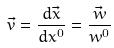<formula> <loc_0><loc_0><loc_500><loc_500>\vec { v } = \frac { d \vec { x } } { d x ^ { 0 } } = \frac { \vec { w } } { w ^ { 0 } }</formula> 